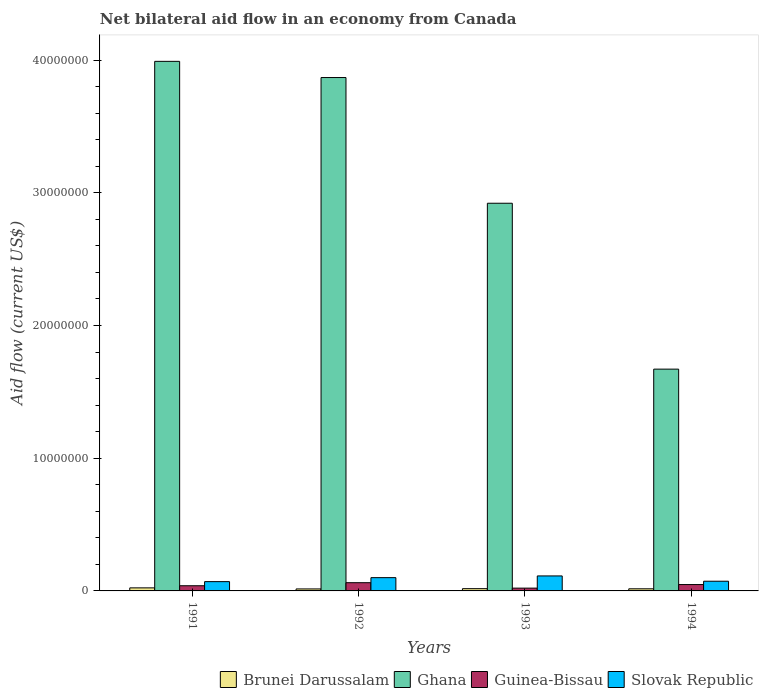How many different coloured bars are there?
Offer a very short reply. 4. How many groups of bars are there?
Your answer should be compact. 4. How many bars are there on the 2nd tick from the left?
Provide a short and direct response. 4. How many bars are there on the 2nd tick from the right?
Make the answer very short. 4. Across all years, what is the maximum net bilateral aid flow in Guinea-Bissau?
Make the answer very short. 6.20e+05. Across all years, what is the minimum net bilateral aid flow in Slovak Republic?
Your answer should be very brief. 7.00e+05. In which year was the net bilateral aid flow in Ghana minimum?
Your response must be concise. 1994. What is the total net bilateral aid flow in Brunei Darussalam in the graph?
Your response must be concise. 7.10e+05. What is the difference between the net bilateral aid flow in Ghana in 1991 and that in 1993?
Your response must be concise. 1.07e+07. What is the difference between the net bilateral aid flow in Guinea-Bissau in 1991 and the net bilateral aid flow in Ghana in 1994?
Provide a succinct answer. -1.63e+07. What is the average net bilateral aid flow in Slovak Republic per year?
Provide a short and direct response. 8.90e+05. In the year 1992, what is the difference between the net bilateral aid flow in Brunei Darussalam and net bilateral aid flow in Guinea-Bissau?
Your answer should be compact. -4.70e+05. What is the ratio of the net bilateral aid flow in Guinea-Bissau in 1992 to that in 1994?
Provide a succinct answer. 1.29. Is the net bilateral aid flow in Ghana in 1991 less than that in 1993?
Keep it short and to the point. No. What is the difference between the highest and the second highest net bilateral aid flow in Slovak Republic?
Your answer should be compact. 1.30e+05. What is the difference between the highest and the lowest net bilateral aid flow in Slovak Republic?
Make the answer very short. 4.30e+05. In how many years, is the net bilateral aid flow in Slovak Republic greater than the average net bilateral aid flow in Slovak Republic taken over all years?
Provide a short and direct response. 2. Is the sum of the net bilateral aid flow in Brunei Darussalam in 1991 and 1992 greater than the maximum net bilateral aid flow in Guinea-Bissau across all years?
Offer a terse response. No. What does the 1st bar from the left in 1992 represents?
Offer a terse response. Brunei Darussalam. How many bars are there?
Provide a succinct answer. 16. Are all the bars in the graph horizontal?
Offer a terse response. No. What is the difference between two consecutive major ticks on the Y-axis?
Give a very brief answer. 1.00e+07. Does the graph contain grids?
Make the answer very short. No. Where does the legend appear in the graph?
Your answer should be very brief. Bottom right. How many legend labels are there?
Give a very brief answer. 4. How are the legend labels stacked?
Offer a terse response. Horizontal. What is the title of the graph?
Your answer should be very brief. Net bilateral aid flow in an economy from Canada. What is the label or title of the Y-axis?
Provide a succinct answer. Aid flow (current US$). What is the Aid flow (current US$) in Brunei Darussalam in 1991?
Provide a short and direct response. 2.30e+05. What is the Aid flow (current US$) of Ghana in 1991?
Your answer should be compact. 3.99e+07. What is the Aid flow (current US$) in Slovak Republic in 1991?
Keep it short and to the point. 7.00e+05. What is the Aid flow (current US$) in Brunei Darussalam in 1992?
Your answer should be very brief. 1.50e+05. What is the Aid flow (current US$) in Ghana in 1992?
Provide a succinct answer. 3.87e+07. What is the Aid flow (current US$) in Guinea-Bissau in 1992?
Offer a very short reply. 6.20e+05. What is the Aid flow (current US$) of Brunei Darussalam in 1993?
Offer a terse response. 1.70e+05. What is the Aid flow (current US$) in Ghana in 1993?
Your answer should be very brief. 2.92e+07. What is the Aid flow (current US$) in Slovak Republic in 1993?
Give a very brief answer. 1.13e+06. What is the Aid flow (current US$) of Brunei Darussalam in 1994?
Offer a terse response. 1.60e+05. What is the Aid flow (current US$) in Ghana in 1994?
Your answer should be compact. 1.67e+07. What is the Aid flow (current US$) in Slovak Republic in 1994?
Make the answer very short. 7.30e+05. Across all years, what is the maximum Aid flow (current US$) of Ghana?
Make the answer very short. 3.99e+07. Across all years, what is the maximum Aid flow (current US$) of Guinea-Bissau?
Offer a very short reply. 6.20e+05. Across all years, what is the maximum Aid flow (current US$) of Slovak Republic?
Keep it short and to the point. 1.13e+06. Across all years, what is the minimum Aid flow (current US$) of Brunei Darussalam?
Your answer should be compact. 1.50e+05. Across all years, what is the minimum Aid flow (current US$) of Ghana?
Offer a terse response. 1.67e+07. What is the total Aid flow (current US$) of Brunei Darussalam in the graph?
Your answer should be very brief. 7.10e+05. What is the total Aid flow (current US$) of Ghana in the graph?
Your answer should be compact. 1.24e+08. What is the total Aid flow (current US$) in Guinea-Bissau in the graph?
Offer a very short reply. 1.70e+06. What is the total Aid flow (current US$) in Slovak Republic in the graph?
Give a very brief answer. 3.56e+06. What is the difference between the Aid flow (current US$) in Brunei Darussalam in 1991 and that in 1992?
Provide a short and direct response. 8.00e+04. What is the difference between the Aid flow (current US$) in Ghana in 1991 and that in 1992?
Your response must be concise. 1.22e+06. What is the difference between the Aid flow (current US$) of Guinea-Bissau in 1991 and that in 1992?
Your response must be concise. -2.30e+05. What is the difference between the Aid flow (current US$) of Slovak Republic in 1991 and that in 1992?
Ensure brevity in your answer.  -3.00e+05. What is the difference between the Aid flow (current US$) of Ghana in 1991 and that in 1993?
Ensure brevity in your answer.  1.07e+07. What is the difference between the Aid flow (current US$) of Slovak Republic in 1991 and that in 1993?
Offer a terse response. -4.30e+05. What is the difference between the Aid flow (current US$) in Ghana in 1991 and that in 1994?
Your answer should be very brief. 2.32e+07. What is the difference between the Aid flow (current US$) of Slovak Republic in 1991 and that in 1994?
Provide a succinct answer. -3.00e+04. What is the difference between the Aid flow (current US$) in Brunei Darussalam in 1992 and that in 1993?
Your answer should be very brief. -2.00e+04. What is the difference between the Aid flow (current US$) in Ghana in 1992 and that in 1993?
Provide a succinct answer. 9.47e+06. What is the difference between the Aid flow (current US$) of Guinea-Bissau in 1992 and that in 1993?
Offer a very short reply. 4.10e+05. What is the difference between the Aid flow (current US$) in Ghana in 1992 and that in 1994?
Your answer should be compact. 2.20e+07. What is the difference between the Aid flow (current US$) of Ghana in 1993 and that in 1994?
Offer a terse response. 1.25e+07. What is the difference between the Aid flow (current US$) of Guinea-Bissau in 1993 and that in 1994?
Offer a very short reply. -2.70e+05. What is the difference between the Aid flow (current US$) in Slovak Republic in 1993 and that in 1994?
Your answer should be compact. 4.00e+05. What is the difference between the Aid flow (current US$) in Brunei Darussalam in 1991 and the Aid flow (current US$) in Ghana in 1992?
Your answer should be compact. -3.84e+07. What is the difference between the Aid flow (current US$) in Brunei Darussalam in 1991 and the Aid flow (current US$) in Guinea-Bissau in 1992?
Give a very brief answer. -3.90e+05. What is the difference between the Aid flow (current US$) of Brunei Darussalam in 1991 and the Aid flow (current US$) of Slovak Republic in 1992?
Your response must be concise. -7.70e+05. What is the difference between the Aid flow (current US$) in Ghana in 1991 and the Aid flow (current US$) in Guinea-Bissau in 1992?
Offer a very short reply. 3.93e+07. What is the difference between the Aid flow (current US$) in Ghana in 1991 and the Aid flow (current US$) in Slovak Republic in 1992?
Make the answer very short. 3.89e+07. What is the difference between the Aid flow (current US$) in Guinea-Bissau in 1991 and the Aid flow (current US$) in Slovak Republic in 1992?
Provide a succinct answer. -6.10e+05. What is the difference between the Aid flow (current US$) in Brunei Darussalam in 1991 and the Aid flow (current US$) in Ghana in 1993?
Your answer should be compact. -2.90e+07. What is the difference between the Aid flow (current US$) of Brunei Darussalam in 1991 and the Aid flow (current US$) of Guinea-Bissau in 1993?
Your answer should be compact. 2.00e+04. What is the difference between the Aid flow (current US$) of Brunei Darussalam in 1991 and the Aid flow (current US$) of Slovak Republic in 1993?
Provide a succinct answer. -9.00e+05. What is the difference between the Aid flow (current US$) in Ghana in 1991 and the Aid flow (current US$) in Guinea-Bissau in 1993?
Provide a succinct answer. 3.97e+07. What is the difference between the Aid flow (current US$) of Ghana in 1991 and the Aid flow (current US$) of Slovak Republic in 1993?
Provide a short and direct response. 3.88e+07. What is the difference between the Aid flow (current US$) of Guinea-Bissau in 1991 and the Aid flow (current US$) of Slovak Republic in 1993?
Make the answer very short. -7.40e+05. What is the difference between the Aid flow (current US$) in Brunei Darussalam in 1991 and the Aid flow (current US$) in Ghana in 1994?
Your answer should be very brief. -1.65e+07. What is the difference between the Aid flow (current US$) of Brunei Darussalam in 1991 and the Aid flow (current US$) of Slovak Republic in 1994?
Your answer should be compact. -5.00e+05. What is the difference between the Aid flow (current US$) of Ghana in 1991 and the Aid flow (current US$) of Guinea-Bissau in 1994?
Provide a succinct answer. 3.94e+07. What is the difference between the Aid flow (current US$) of Ghana in 1991 and the Aid flow (current US$) of Slovak Republic in 1994?
Offer a terse response. 3.92e+07. What is the difference between the Aid flow (current US$) of Brunei Darussalam in 1992 and the Aid flow (current US$) of Ghana in 1993?
Ensure brevity in your answer.  -2.91e+07. What is the difference between the Aid flow (current US$) in Brunei Darussalam in 1992 and the Aid flow (current US$) in Guinea-Bissau in 1993?
Your answer should be compact. -6.00e+04. What is the difference between the Aid flow (current US$) in Brunei Darussalam in 1992 and the Aid flow (current US$) in Slovak Republic in 1993?
Your answer should be compact. -9.80e+05. What is the difference between the Aid flow (current US$) in Ghana in 1992 and the Aid flow (current US$) in Guinea-Bissau in 1993?
Offer a very short reply. 3.85e+07. What is the difference between the Aid flow (current US$) in Ghana in 1992 and the Aid flow (current US$) in Slovak Republic in 1993?
Keep it short and to the point. 3.76e+07. What is the difference between the Aid flow (current US$) of Guinea-Bissau in 1992 and the Aid flow (current US$) of Slovak Republic in 1993?
Your response must be concise. -5.10e+05. What is the difference between the Aid flow (current US$) in Brunei Darussalam in 1992 and the Aid flow (current US$) in Ghana in 1994?
Offer a terse response. -1.66e+07. What is the difference between the Aid flow (current US$) of Brunei Darussalam in 1992 and the Aid flow (current US$) of Guinea-Bissau in 1994?
Ensure brevity in your answer.  -3.30e+05. What is the difference between the Aid flow (current US$) in Brunei Darussalam in 1992 and the Aid flow (current US$) in Slovak Republic in 1994?
Your response must be concise. -5.80e+05. What is the difference between the Aid flow (current US$) of Ghana in 1992 and the Aid flow (current US$) of Guinea-Bissau in 1994?
Offer a very short reply. 3.82e+07. What is the difference between the Aid flow (current US$) in Ghana in 1992 and the Aid flow (current US$) in Slovak Republic in 1994?
Keep it short and to the point. 3.80e+07. What is the difference between the Aid flow (current US$) in Guinea-Bissau in 1992 and the Aid flow (current US$) in Slovak Republic in 1994?
Give a very brief answer. -1.10e+05. What is the difference between the Aid flow (current US$) in Brunei Darussalam in 1993 and the Aid flow (current US$) in Ghana in 1994?
Provide a short and direct response. -1.65e+07. What is the difference between the Aid flow (current US$) of Brunei Darussalam in 1993 and the Aid flow (current US$) of Guinea-Bissau in 1994?
Ensure brevity in your answer.  -3.10e+05. What is the difference between the Aid flow (current US$) of Brunei Darussalam in 1993 and the Aid flow (current US$) of Slovak Republic in 1994?
Ensure brevity in your answer.  -5.60e+05. What is the difference between the Aid flow (current US$) in Ghana in 1993 and the Aid flow (current US$) in Guinea-Bissau in 1994?
Your answer should be compact. 2.87e+07. What is the difference between the Aid flow (current US$) of Ghana in 1993 and the Aid flow (current US$) of Slovak Republic in 1994?
Ensure brevity in your answer.  2.85e+07. What is the difference between the Aid flow (current US$) of Guinea-Bissau in 1993 and the Aid flow (current US$) of Slovak Republic in 1994?
Make the answer very short. -5.20e+05. What is the average Aid flow (current US$) in Brunei Darussalam per year?
Your answer should be compact. 1.78e+05. What is the average Aid flow (current US$) in Ghana per year?
Make the answer very short. 3.11e+07. What is the average Aid flow (current US$) in Guinea-Bissau per year?
Give a very brief answer. 4.25e+05. What is the average Aid flow (current US$) in Slovak Republic per year?
Give a very brief answer. 8.90e+05. In the year 1991, what is the difference between the Aid flow (current US$) in Brunei Darussalam and Aid flow (current US$) in Ghana?
Provide a succinct answer. -3.97e+07. In the year 1991, what is the difference between the Aid flow (current US$) of Brunei Darussalam and Aid flow (current US$) of Guinea-Bissau?
Your answer should be very brief. -1.60e+05. In the year 1991, what is the difference between the Aid flow (current US$) of Brunei Darussalam and Aid flow (current US$) of Slovak Republic?
Offer a very short reply. -4.70e+05. In the year 1991, what is the difference between the Aid flow (current US$) of Ghana and Aid flow (current US$) of Guinea-Bissau?
Offer a very short reply. 3.95e+07. In the year 1991, what is the difference between the Aid flow (current US$) of Ghana and Aid flow (current US$) of Slovak Republic?
Offer a terse response. 3.92e+07. In the year 1991, what is the difference between the Aid flow (current US$) in Guinea-Bissau and Aid flow (current US$) in Slovak Republic?
Provide a short and direct response. -3.10e+05. In the year 1992, what is the difference between the Aid flow (current US$) in Brunei Darussalam and Aid flow (current US$) in Ghana?
Offer a very short reply. -3.85e+07. In the year 1992, what is the difference between the Aid flow (current US$) in Brunei Darussalam and Aid flow (current US$) in Guinea-Bissau?
Your answer should be very brief. -4.70e+05. In the year 1992, what is the difference between the Aid flow (current US$) in Brunei Darussalam and Aid flow (current US$) in Slovak Republic?
Offer a very short reply. -8.50e+05. In the year 1992, what is the difference between the Aid flow (current US$) in Ghana and Aid flow (current US$) in Guinea-Bissau?
Your answer should be very brief. 3.81e+07. In the year 1992, what is the difference between the Aid flow (current US$) in Ghana and Aid flow (current US$) in Slovak Republic?
Keep it short and to the point. 3.77e+07. In the year 1992, what is the difference between the Aid flow (current US$) of Guinea-Bissau and Aid flow (current US$) of Slovak Republic?
Keep it short and to the point. -3.80e+05. In the year 1993, what is the difference between the Aid flow (current US$) of Brunei Darussalam and Aid flow (current US$) of Ghana?
Give a very brief answer. -2.90e+07. In the year 1993, what is the difference between the Aid flow (current US$) in Brunei Darussalam and Aid flow (current US$) in Slovak Republic?
Your answer should be compact. -9.60e+05. In the year 1993, what is the difference between the Aid flow (current US$) in Ghana and Aid flow (current US$) in Guinea-Bissau?
Your answer should be compact. 2.90e+07. In the year 1993, what is the difference between the Aid flow (current US$) in Ghana and Aid flow (current US$) in Slovak Republic?
Offer a very short reply. 2.81e+07. In the year 1993, what is the difference between the Aid flow (current US$) of Guinea-Bissau and Aid flow (current US$) of Slovak Republic?
Offer a very short reply. -9.20e+05. In the year 1994, what is the difference between the Aid flow (current US$) of Brunei Darussalam and Aid flow (current US$) of Ghana?
Ensure brevity in your answer.  -1.66e+07. In the year 1994, what is the difference between the Aid flow (current US$) in Brunei Darussalam and Aid flow (current US$) in Guinea-Bissau?
Offer a terse response. -3.20e+05. In the year 1994, what is the difference between the Aid flow (current US$) in Brunei Darussalam and Aid flow (current US$) in Slovak Republic?
Provide a short and direct response. -5.70e+05. In the year 1994, what is the difference between the Aid flow (current US$) in Ghana and Aid flow (current US$) in Guinea-Bissau?
Your answer should be very brief. 1.62e+07. In the year 1994, what is the difference between the Aid flow (current US$) in Ghana and Aid flow (current US$) in Slovak Republic?
Your answer should be very brief. 1.60e+07. What is the ratio of the Aid flow (current US$) in Brunei Darussalam in 1991 to that in 1992?
Give a very brief answer. 1.53. What is the ratio of the Aid flow (current US$) in Ghana in 1991 to that in 1992?
Ensure brevity in your answer.  1.03. What is the ratio of the Aid flow (current US$) in Guinea-Bissau in 1991 to that in 1992?
Your response must be concise. 0.63. What is the ratio of the Aid flow (current US$) of Slovak Republic in 1991 to that in 1992?
Provide a succinct answer. 0.7. What is the ratio of the Aid flow (current US$) of Brunei Darussalam in 1991 to that in 1993?
Your answer should be compact. 1.35. What is the ratio of the Aid flow (current US$) of Ghana in 1991 to that in 1993?
Offer a terse response. 1.37. What is the ratio of the Aid flow (current US$) of Guinea-Bissau in 1991 to that in 1993?
Your answer should be compact. 1.86. What is the ratio of the Aid flow (current US$) in Slovak Republic in 1991 to that in 1993?
Ensure brevity in your answer.  0.62. What is the ratio of the Aid flow (current US$) in Brunei Darussalam in 1991 to that in 1994?
Offer a terse response. 1.44. What is the ratio of the Aid flow (current US$) of Ghana in 1991 to that in 1994?
Provide a succinct answer. 2.39. What is the ratio of the Aid flow (current US$) in Guinea-Bissau in 1991 to that in 1994?
Offer a terse response. 0.81. What is the ratio of the Aid flow (current US$) of Slovak Republic in 1991 to that in 1994?
Keep it short and to the point. 0.96. What is the ratio of the Aid flow (current US$) in Brunei Darussalam in 1992 to that in 1993?
Provide a short and direct response. 0.88. What is the ratio of the Aid flow (current US$) of Ghana in 1992 to that in 1993?
Your answer should be very brief. 1.32. What is the ratio of the Aid flow (current US$) in Guinea-Bissau in 1992 to that in 1993?
Your answer should be compact. 2.95. What is the ratio of the Aid flow (current US$) of Slovak Republic in 1992 to that in 1993?
Your answer should be very brief. 0.89. What is the ratio of the Aid flow (current US$) of Brunei Darussalam in 1992 to that in 1994?
Your response must be concise. 0.94. What is the ratio of the Aid flow (current US$) in Ghana in 1992 to that in 1994?
Provide a short and direct response. 2.31. What is the ratio of the Aid flow (current US$) in Guinea-Bissau in 1992 to that in 1994?
Your answer should be very brief. 1.29. What is the ratio of the Aid flow (current US$) in Slovak Republic in 1992 to that in 1994?
Your answer should be compact. 1.37. What is the ratio of the Aid flow (current US$) of Brunei Darussalam in 1993 to that in 1994?
Give a very brief answer. 1.06. What is the ratio of the Aid flow (current US$) in Ghana in 1993 to that in 1994?
Your answer should be very brief. 1.75. What is the ratio of the Aid flow (current US$) in Guinea-Bissau in 1993 to that in 1994?
Offer a terse response. 0.44. What is the ratio of the Aid flow (current US$) of Slovak Republic in 1993 to that in 1994?
Your answer should be very brief. 1.55. What is the difference between the highest and the second highest Aid flow (current US$) of Brunei Darussalam?
Offer a terse response. 6.00e+04. What is the difference between the highest and the second highest Aid flow (current US$) of Ghana?
Offer a very short reply. 1.22e+06. What is the difference between the highest and the second highest Aid flow (current US$) in Slovak Republic?
Ensure brevity in your answer.  1.30e+05. What is the difference between the highest and the lowest Aid flow (current US$) of Ghana?
Ensure brevity in your answer.  2.32e+07. What is the difference between the highest and the lowest Aid flow (current US$) in Slovak Republic?
Provide a succinct answer. 4.30e+05. 